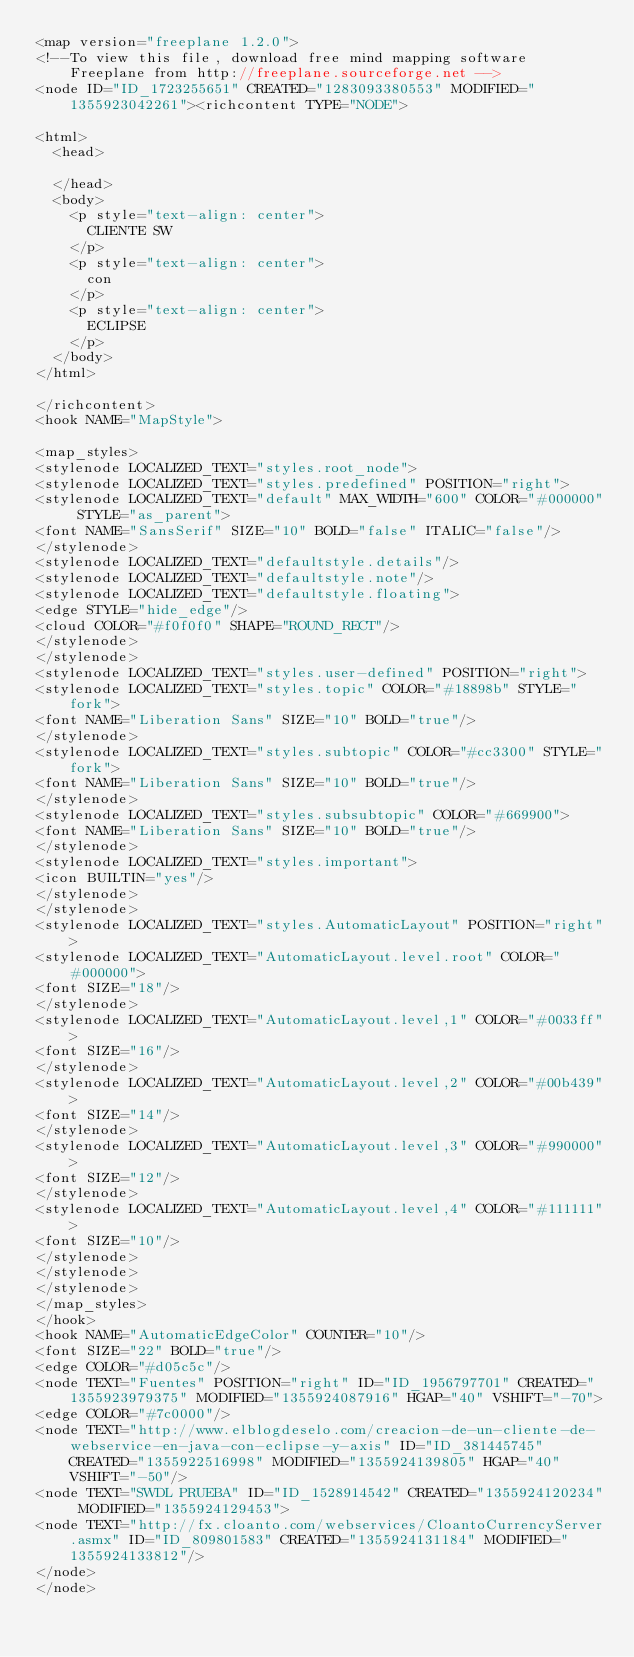<code> <loc_0><loc_0><loc_500><loc_500><_ObjectiveC_><map version="freeplane 1.2.0">
<!--To view this file, download free mind mapping software Freeplane from http://freeplane.sourceforge.net -->
<node ID="ID_1723255651" CREATED="1283093380553" MODIFIED="1355923042261"><richcontent TYPE="NODE">

<html>
  <head>
    
  </head>
  <body>
    <p style="text-align: center">
      CLIENTE SW
    </p>
    <p style="text-align: center">
      con
    </p>
    <p style="text-align: center">
      ECLIPSE
    </p>
  </body>
</html>

</richcontent>
<hook NAME="MapStyle">

<map_styles>
<stylenode LOCALIZED_TEXT="styles.root_node">
<stylenode LOCALIZED_TEXT="styles.predefined" POSITION="right">
<stylenode LOCALIZED_TEXT="default" MAX_WIDTH="600" COLOR="#000000" STYLE="as_parent">
<font NAME="SansSerif" SIZE="10" BOLD="false" ITALIC="false"/>
</stylenode>
<stylenode LOCALIZED_TEXT="defaultstyle.details"/>
<stylenode LOCALIZED_TEXT="defaultstyle.note"/>
<stylenode LOCALIZED_TEXT="defaultstyle.floating">
<edge STYLE="hide_edge"/>
<cloud COLOR="#f0f0f0" SHAPE="ROUND_RECT"/>
</stylenode>
</stylenode>
<stylenode LOCALIZED_TEXT="styles.user-defined" POSITION="right">
<stylenode LOCALIZED_TEXT="styles.topic" COLOR="#18898b" STYLE="fork">
<font NAME="Liberation Sans" SIZE="10" BOLD="true"/>
</stylenode>
<stylenode LOCALIZED_TEXT="styles.subtopic" COLOR="#cc3300" STYLE="fork">
<font NAME="Liberation Sans" SIZE="10" BOLD="true"/>
</stylenode>
<stylenode LOCALIZED_TEXT="styles.subsubtopic" COLOR="#669900">
<font NAME="Liberation Sans" SIZE="10" BOLD="true"/>
</stylenode>
<stylenode LOCALIZED_TEXT="styles.important">
<icon BUILTIN="yes"/>
</stylenode>
</stylenode>
<stylenode LOCALIZED_TEXT="styles.AutomaticLayout" POSITION="right">
<stylenode LOCALIZED_TEXT="AutomaticLayout.level.root" COLOR="#000000">
<font SIZE="18"/>
</stylenode>
<stylenode LOCALIZED_TEXT="AutomaticLayout.level,1" COLOR="#0033ff">
<font SIZE="16"/>
</stylenode>
<stylenode LOCALIZED_TEXT="AutomaticLayout.level,2" COLOR="#00b439">
<font SIZE="14"/>
</stylenode>
<stylenode LOCALIZED_TEXT="AutomaticLayout.level,3" COLOR="#990000">
<font SIZE="12"/>
</stylenode>
<stylenode LOCALIZED_TEXT="AutomaticLayout.level,4" COLOR="#111111">
<font SIZE="10"/>
</stylenode>
</stylenode>
</stylenode>
</map_styles>
</hook>
<hook NAME="AutomaticEdgeColor" COUNTER="10"/>
<font SIZE="22" BOLD="true"/>
<edge COLOR="#d05c5c"/>
<node TEXT="Fuentes" POSITION="right" ID="ID_1956797701" CREATED="1355923979375" MODIFIED="1355924087916" HGAP="40" VSHIFT="-70">
<edge COLOR="#7c0000"/>
<node TEXT="http://www.elblogdeselo.com/creacion-de-un-cliente-de-webservice-en-java-con-eclipse-y-axis" ID="ID_381445745" CREATED="1355922516998" MODIFIED="1355924139805" HGAP="40" VSHIFT="-50"/>
<node TEXT="SWDL PRUEBA" ID="ID_1528914542" CREATED="1355924120234" MODIFIED="1355924129453">
<node TEXT="http://fx.cloanto.com/webservices/CloantoCurrencyServer.asmx" ID="ID_809801583" CREATED="1355924131184" MODIFIED="1355924133812"/>
</node>
</node></code> 